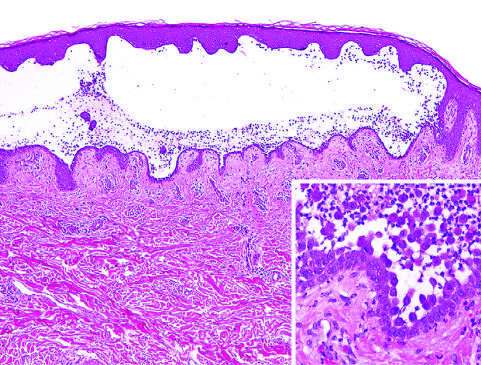what are plentiful?
Answer the question using a single word or phrase. Rounded 